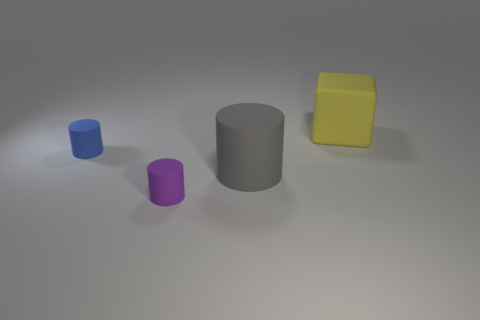There is a large gray object that is the same shape as the purple matte object; what material is it? rubber 